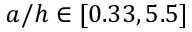Convert formula to latex. <formula><loc_0><loc_0><loc_500><loc_500>a / h \in [ 0 . 3 3 , 5 . 5 ]</formula> 